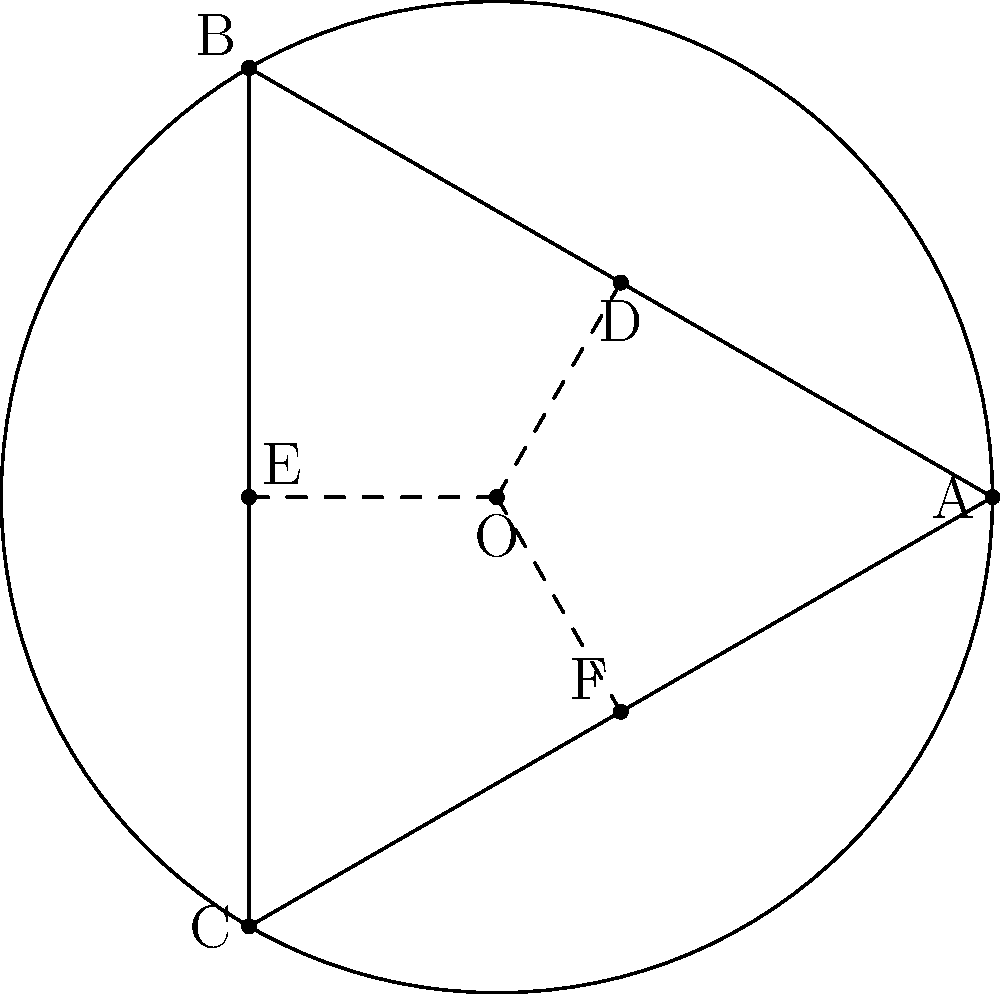In the circle above, triangle ABC is inscribed and lines OD, OE, and OF are drawn from the center O to the sides of the triangle. If the radius of the circle is r, express the length of OD in terms of r. Let's approach this step-by-step:

1) First, note that triangle ABC is equilateral because it's inscribed in a circle with its vertices equally spaced around the circumference.

2) OD is perpendicular to AB. This forms two right triangles: AOD and BOD.

3) In the right triangle AOD:
   - The hypotenuse OA is the radius, r.
   - Angle AOD is 30° (half of 60°, as ABC is equilateral).

4) In a 30-60-90 triangle, the side opposite to the 30° angle is half the hypotenuse.

5) Therefore, OD = $\frac{1}{2}r$

This result showcases the harmony between the circle and the inscribed equilateral triangle, reminiscent of the balance an artist might strive for in their work. The precision of this geometric relationship mirrors the discipline required in both art and military training.
Answer: $\frac{1}{2}r$ 